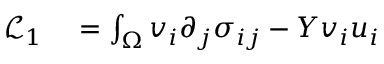<formula> <loc_0><loc_0><loc_500><loc_500>\begin{array} { r l } { \mathcal { L } _ { 1 } } & = \int _ { \Omega } v _ { i } \partial _ { j } \sigma _ { i j } - Y v _ { i } u _ { i } } \end{array}</formula> 